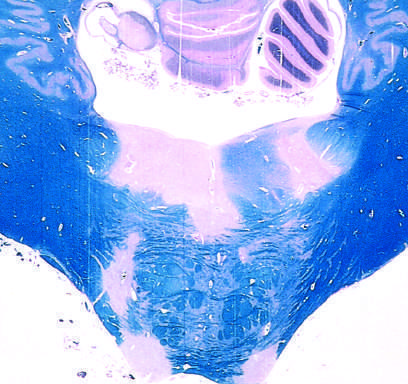does luxol fast blue-periodic acid-schiff stain for myelin?
Answer the question using a single word or phrase. Yes 